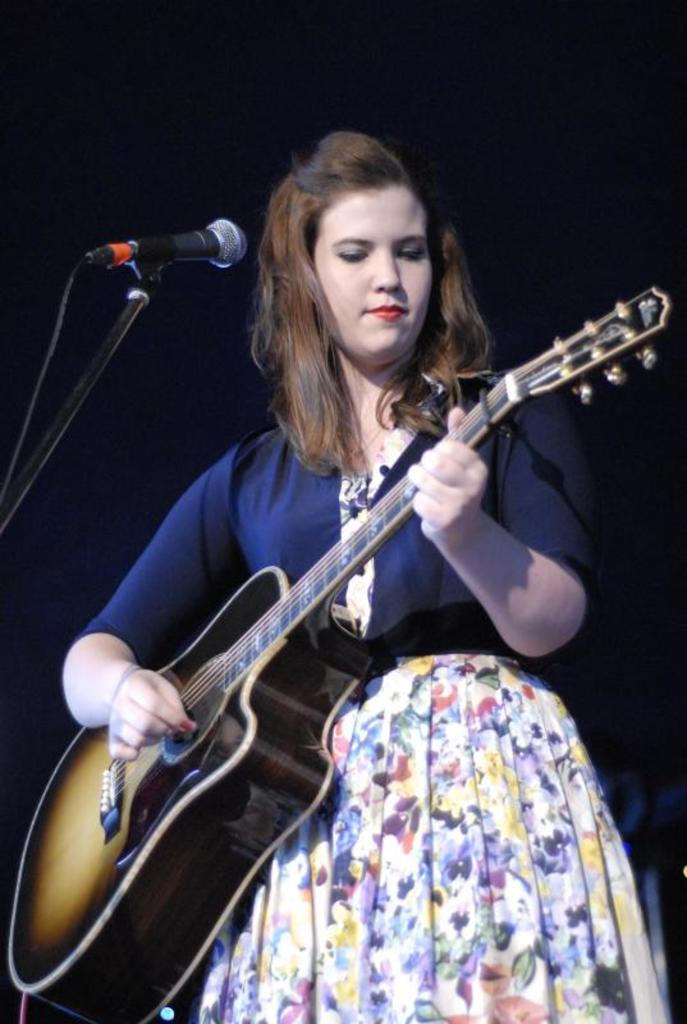What is the main subject of the image? The main subject of the image is a woman. What is the woman doing in the image? The woman is standing in front of a mic and playing a guitar. What color is the background of the image? The background of the image is blue. What type of toothpaste is the woman using in the image? There is no toothpaste present in the image; the woman is playing a guitar and standing in front of a mic. 